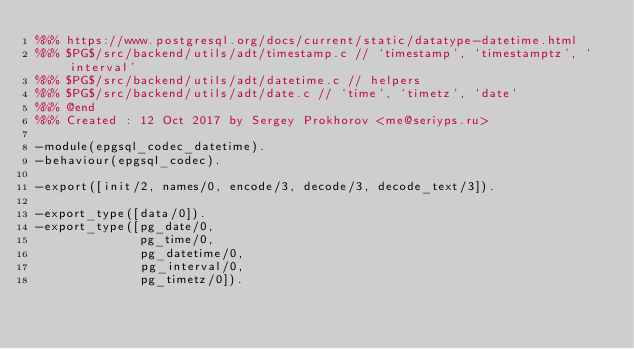Convert code to text. <code><loc_0><loc_0><loc_500><loc_500><_Erlang_>%%% https://www.postgresql.org/docs/current/static/datatype-datetime.html
%%% $PG$/src/backend/utils/adt/timestamp.c // `timestamp', `timestamptz', `interval'
%%% $PG$/src/backend/utils/adt/datetime.c // helpers
%%% $PG$/src/backend/utils/adt/date.c // `time', `timetz', `date'
%%% @end
%%% Created : 12 Oct 2017 by Sergey Prokhorov <me@seriyps.ru>

-module(epgsql_codec_datetime).
-behaviour(epgsql_codec).

-export([init/2, names/0, encode/3, decode/3, decode_text/3]).

-export_type([data/0]).
-export_type([pg_date/0,
              pg_time/0,
              pg_datetime/0,
              pg_interval/0,
              pg_timetz/0]).
</code> 